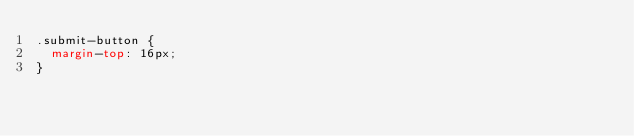Convert code to text. <code><loc_0><loc_0><loc_500><loc_500><_CSS_>.submit-button {
  margin-top: 16px;
}
</code> 